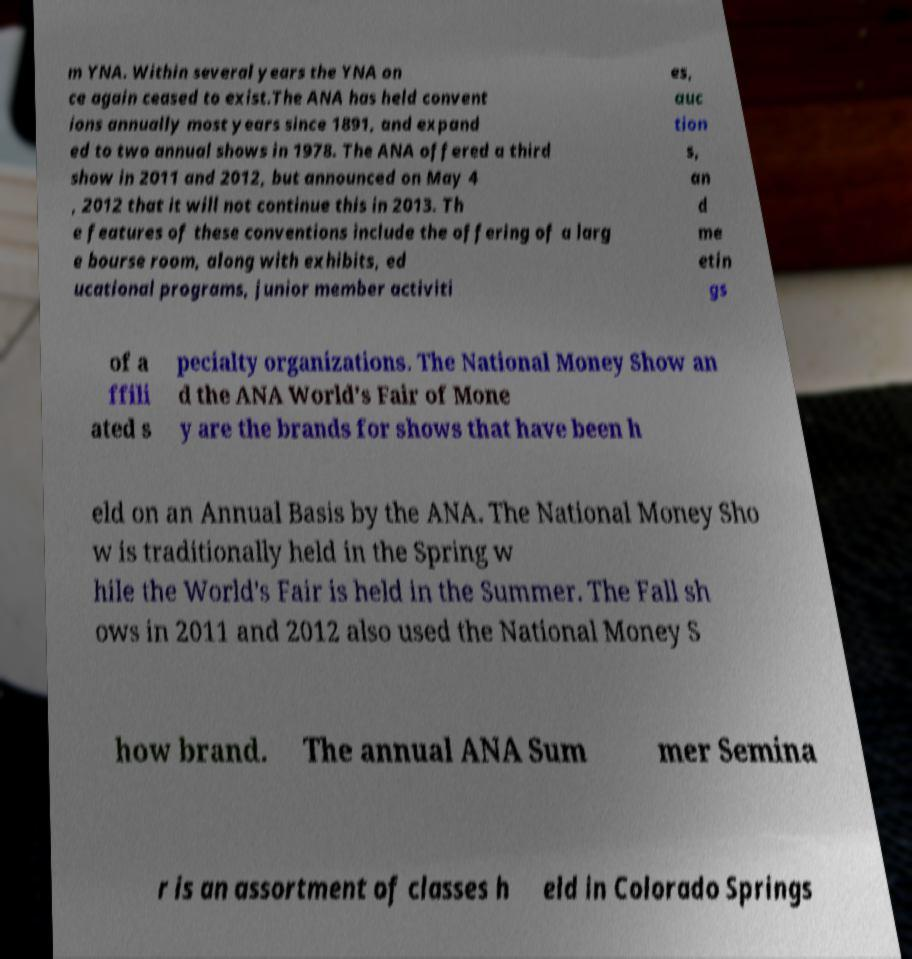Please read and relay the text visible in this image. What does it say? m YNA. Within several years the YNA on ce again ceased to exist.The ANA has held convent ions annually most years since 1891, and expand ed to two annual shows in 1978. The ANA offered a third show in 2011 and 2012, but announced on May 4 , 2012 that it will not continue this in 2013. Th e features of these conventions include the offering of a larg e bourse room, along with exhibits, ed ucational programs, junior member activiti es, auc tion s, an d me etin gs of a ffili ated s pecialty organizations. The National Money Show an d the ANA World's Fair of Mone y are the brands for shows that have been h eld on an Annual Basis by the ANA. The National Money Sho w is traditionally held in the Spring w hile the World's Fair is held in the Summer. The Fall sh ows in 2011 and 2012 also used the National Money S how brand. The annual ANA Sum mer Semina r is an assortment of classes h eld in Colorado Springs 